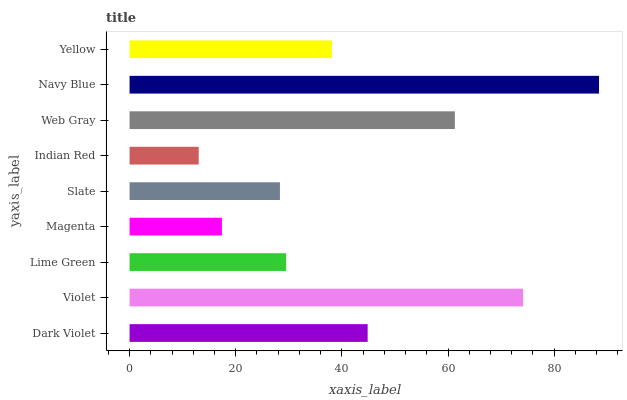Is Indian Red the minimum?
Answer yes or no. Yes. Is Navy Blue the maximum?
Answer yes or no. Yes. Is Violet the minimum?
Answer yes or no. No. Is Violet the maximum?
Answer yes or no. No. Is Violet greater than Dark Violet?
Answer yes or no. Yes. Is Dark Violet less than Violet?
Answer yes or no. Yes. Is Dark Violet greater than Violet?
Answer yes or no. No. Is Violet less than Dark Violet?
Answer yes or no. No. Is Yellow the high median?
Answer yes or no. Yes. Is Yellow the low median?
Answer yes or no. Yes. Is Slate the high median?
Answer yes or no. No. Is Web Gray the low median?
Answer yes or no. No. 